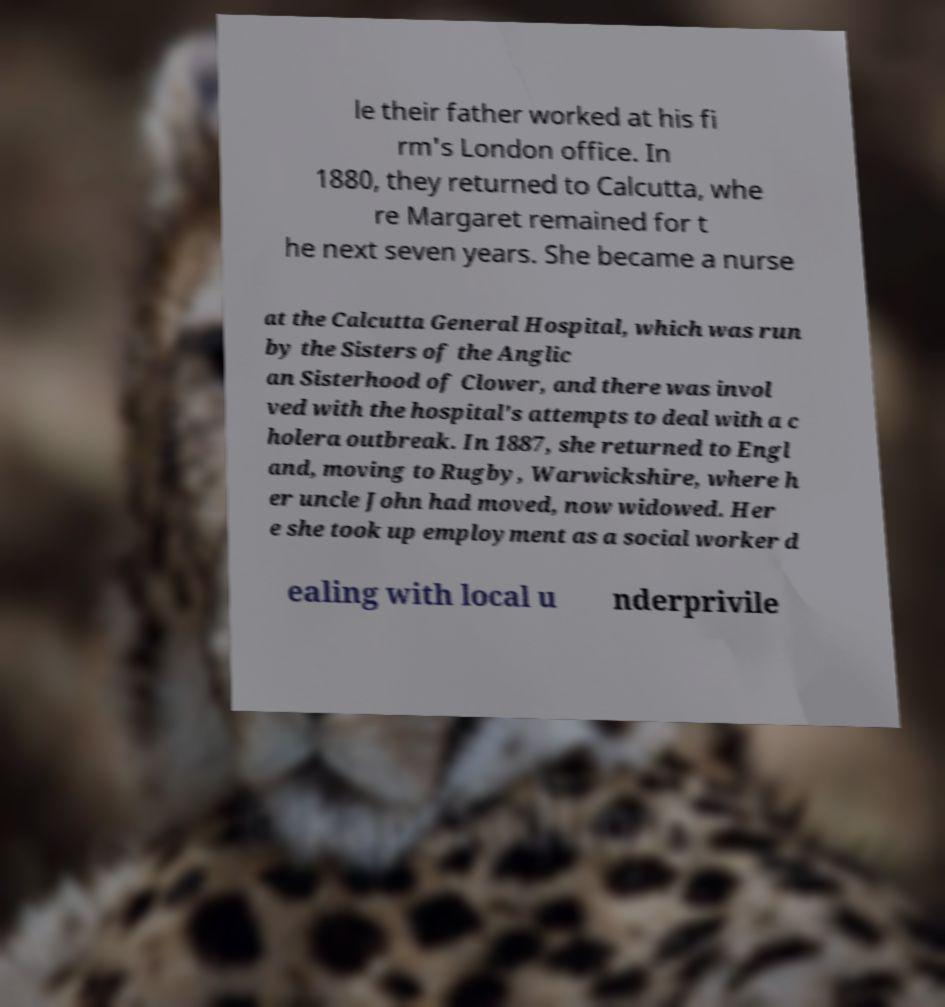There's text embedded in this image that I need extracted. Can you transcribe it verbatim? le their father worked at his fi rm's London office. In 1880, they returned to Calcutta, whe re Margaret remained for t he next seven years. She became a nurse at the Calcutta General Hospital, which was run by the Sisters of the Anglic an Sisterhood of Clower, and there was invol ved with the hospital's attempts to deal with a c holera outbreak. In 1887, she returned to Engl and, moving to Rugby, Warwickshire, where h er uncle John had moved, now widowed. Her e she took up employment as a social worker d ealing with local u nderprivile 